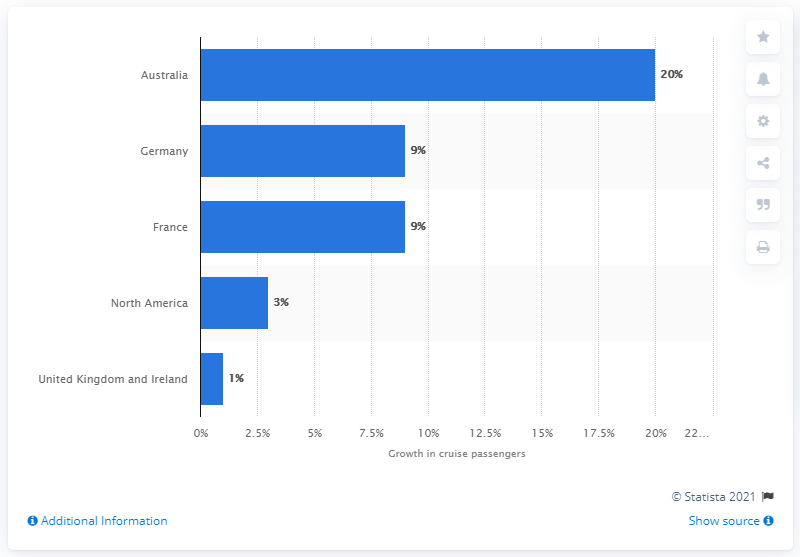Highlight a few significant elements in this photo. In 2013, Australia was the fastest growing source market for cruise passengers. In 2013, Australia had approximately 8.8% of the world's total number of international air passengers. 